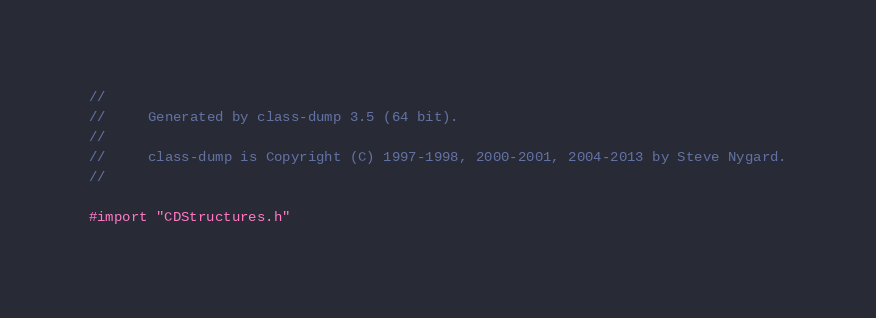<code> <loc_0><loc_0><loc_500><loc_500><_C_>//
//     Generated by class-dump 3.5 (64 bit).
//
//     class-dump is Copyright (C) 1997-1998, 2000-2001, 2004-2013 by Steve Nygard.
//

#import "CDStructures.h"
</code> 